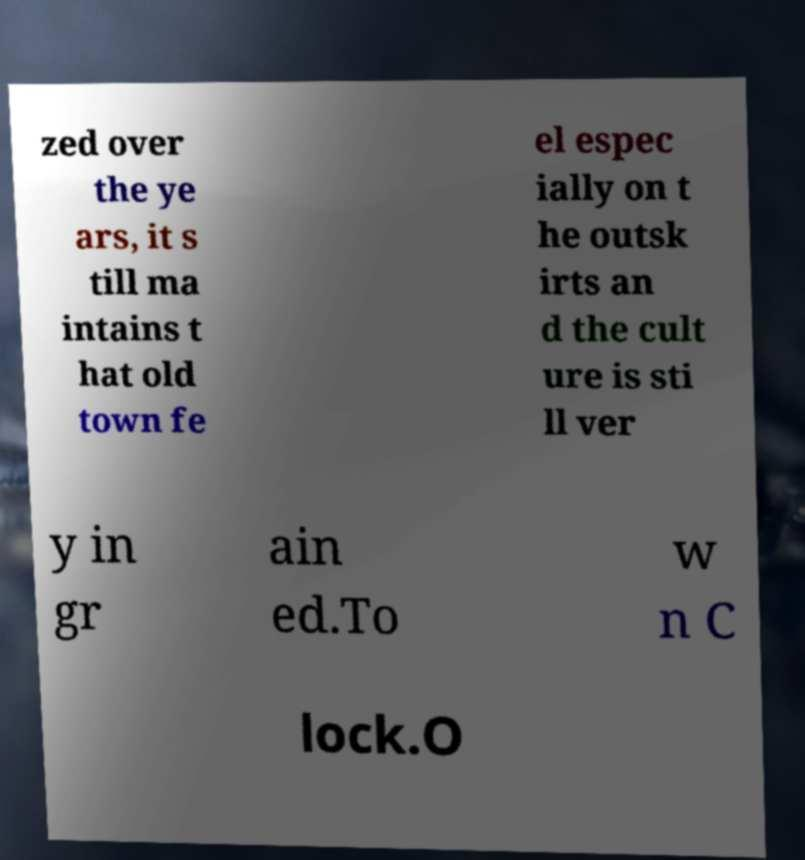Could you extract and type out the text from this image? zed over the ye ars, it s till ma intains t hat old town fe el espec ially on t he outsk irts an d the cult ure is sti ll ver y in gr ain ed.To w n C lock.O 